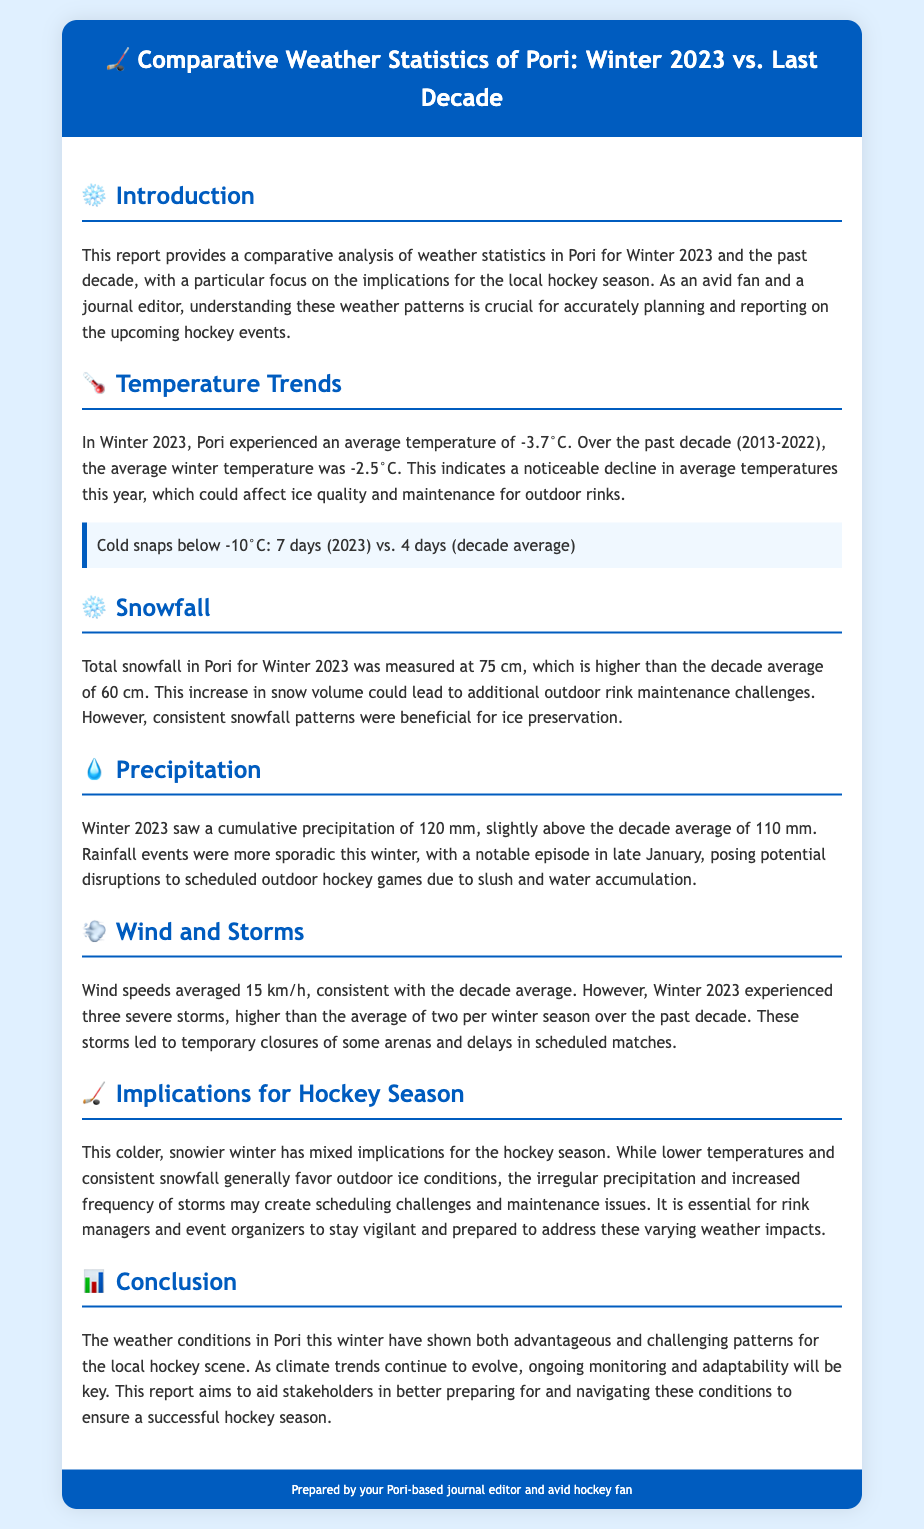What was the average temperature in Winter 2023? The average temperature in Winter 2023 was -3.7°C, as stated in the document.
Answer: -3.7°C How many cold snap days were recorded in Winter 2023? The document specifies that there were 7 days with cold snaps below -10°C in Winter 2023.
Answer: 7 days What was the total snowfall measured for Winter 2023? According to the report, total snowfall for Winter 2023 was 75 cm.
Answer: 75 cm What is the decade average for total snowfall? The decade average for total snowfall was mentioned as 60 cm in the document.
Answer: 60 cm How many severe storms occurred in Winter 2023? The document notes that Winter 2023 experienced three severe storms.
Answer: Three What impact does consistent snowfall have on ice preservation? The document implies that consistent snowfall patterns were beneficial for ice preservation.
Answer: Beneficial What are the implications of irregular precipitation for outdoor hockey games? The report mentions that irregular precipitation poses potential disruptions to scheduled outdoor hockey games.
Answer: Disruptions How does the average wind speed in Winter 2023 compare to the decade average? The document states that the average wind speed of 15 km/h in Winter 2023 was consistent with the decade average.
Answer: Consistent What does the conclusion suggest about climate trends? The conclusion indicates that ongoing monitoring and adaptability will be key as climate trends continue to evolve.
Answer: Key 